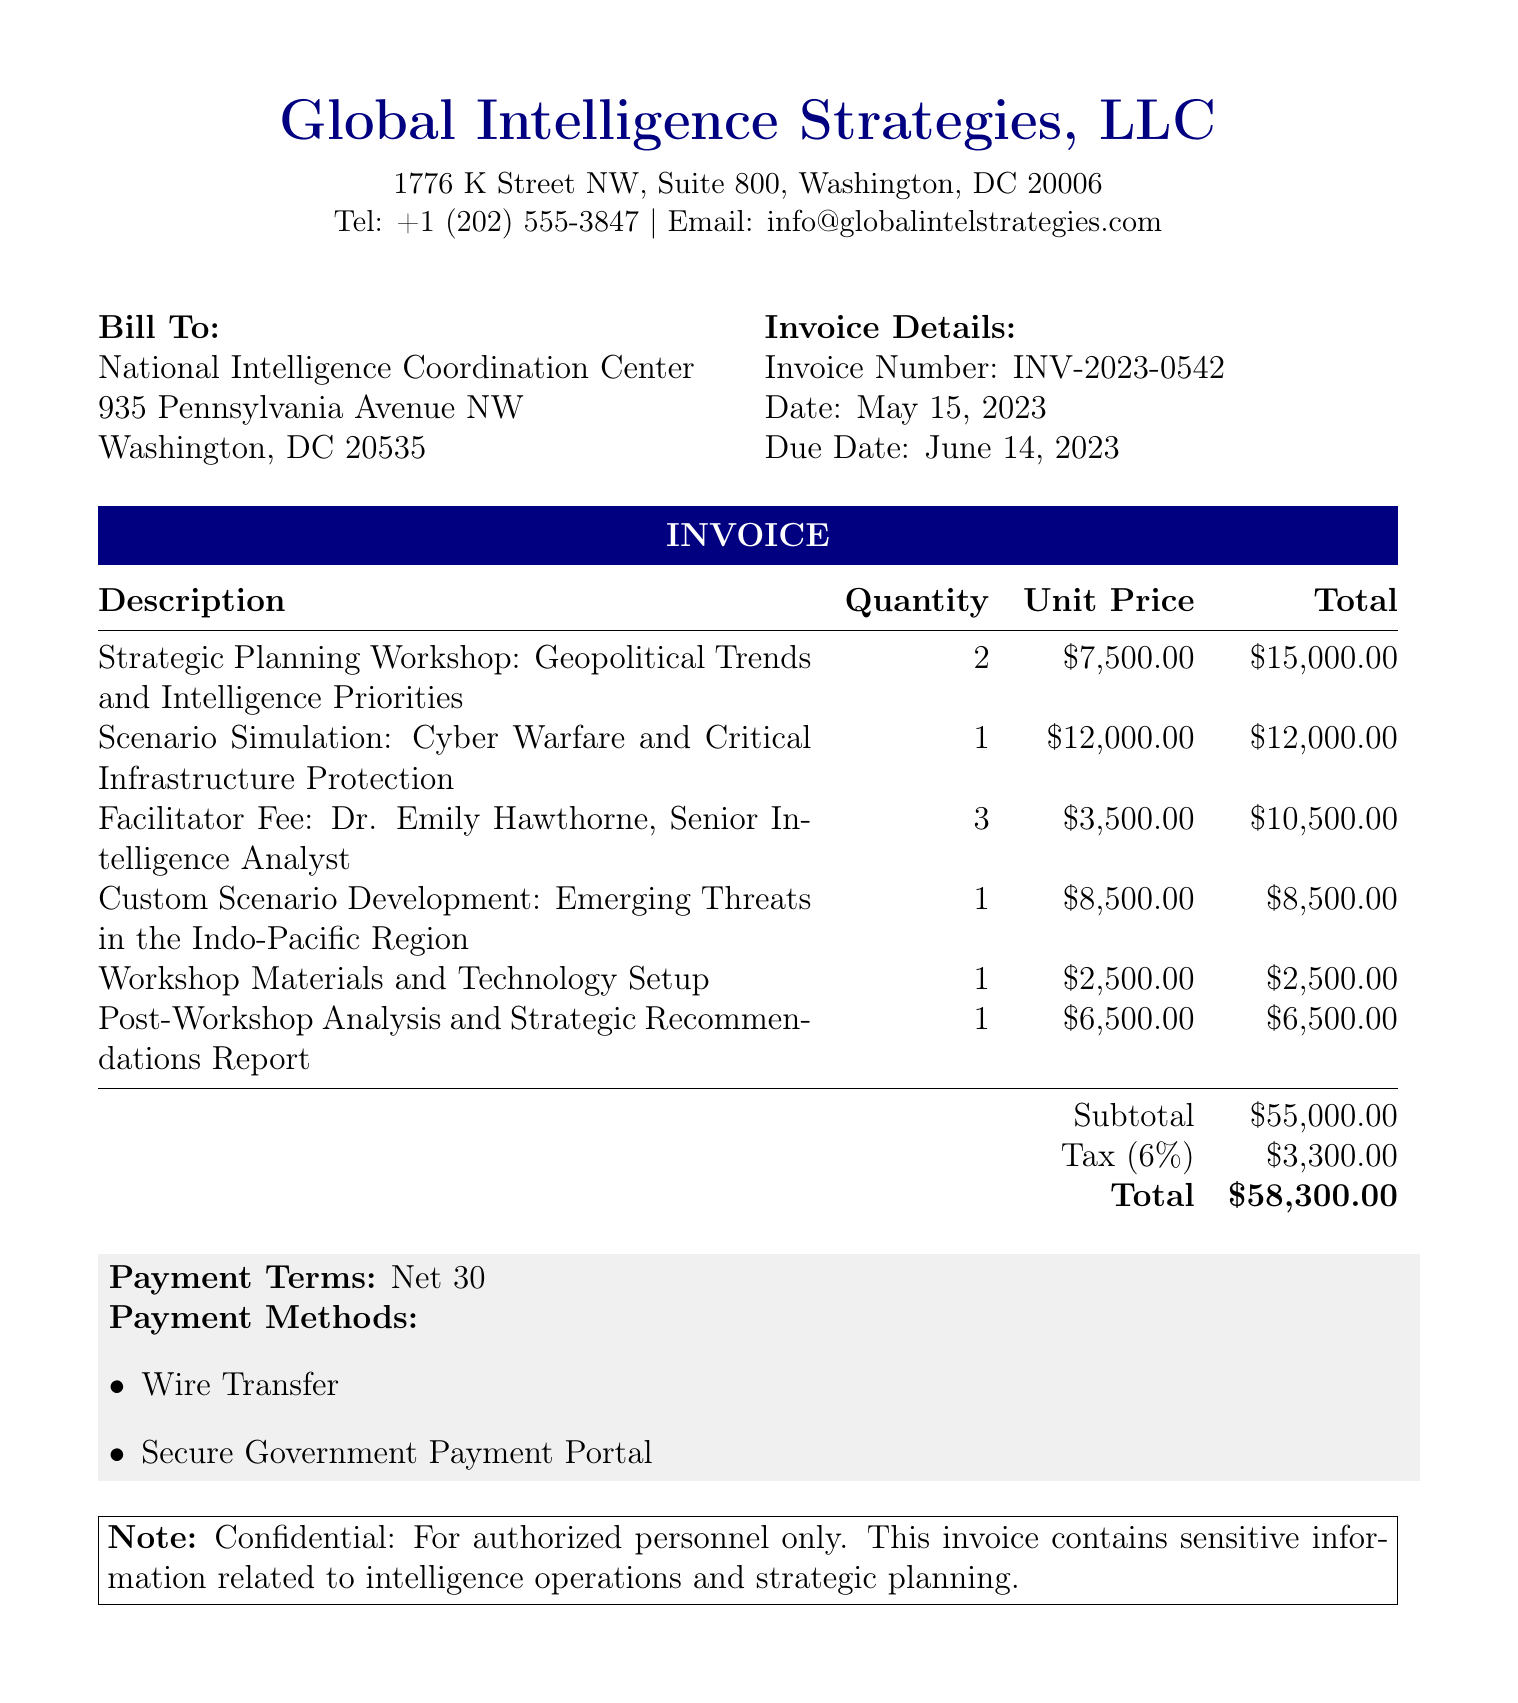What is the invoice number? The invoice number can be found in the invoice details section of the document, which is given as INV-2023-0542.
Answer: INV-2023-0542 Who is the client? The client is listed at the beginning of the document under the "Bill To" section, which names the National Intelligence Coordination Center.
Answer: National Intelligence Coordination Center What is the total amount due? The total amount due is listed at the bottom of the invoice after the subtotal and tax calculations, which is $58,300.00.
Answer: $58,300.00 How many facilitators are accounted for in the invoice? The invoice includes the facilitator fee for Dr. Emily Hawthorne with a quantity of 3, indicating three sessions she facilitated.
Answer: 3 What is the tax rate applied to the invoice? The tax rate can be found within the financial details of the invoice, indicated as 6%.
Answer: 6% What is the due date for the invoice payment? The due date is shown in the invoice details section as June 14, 2023.
Answer: June 14, 2023 What kind of scenarios were simulated during the workshops? The description of the scenario simulation indicates a focus on Cyber Warfare and Critical Infrastructure Protection, giving insight into the context of the workshops.
Answer: Cyber Warfare and Critical Infrastructure Protection What payment methods are accepted? The accepted payment methods are listed in the payment terms section, specifying Wire Transfer and Secure Government Payment Portal.
Answer: Wire Transfer, Secure Government Payment Portal 